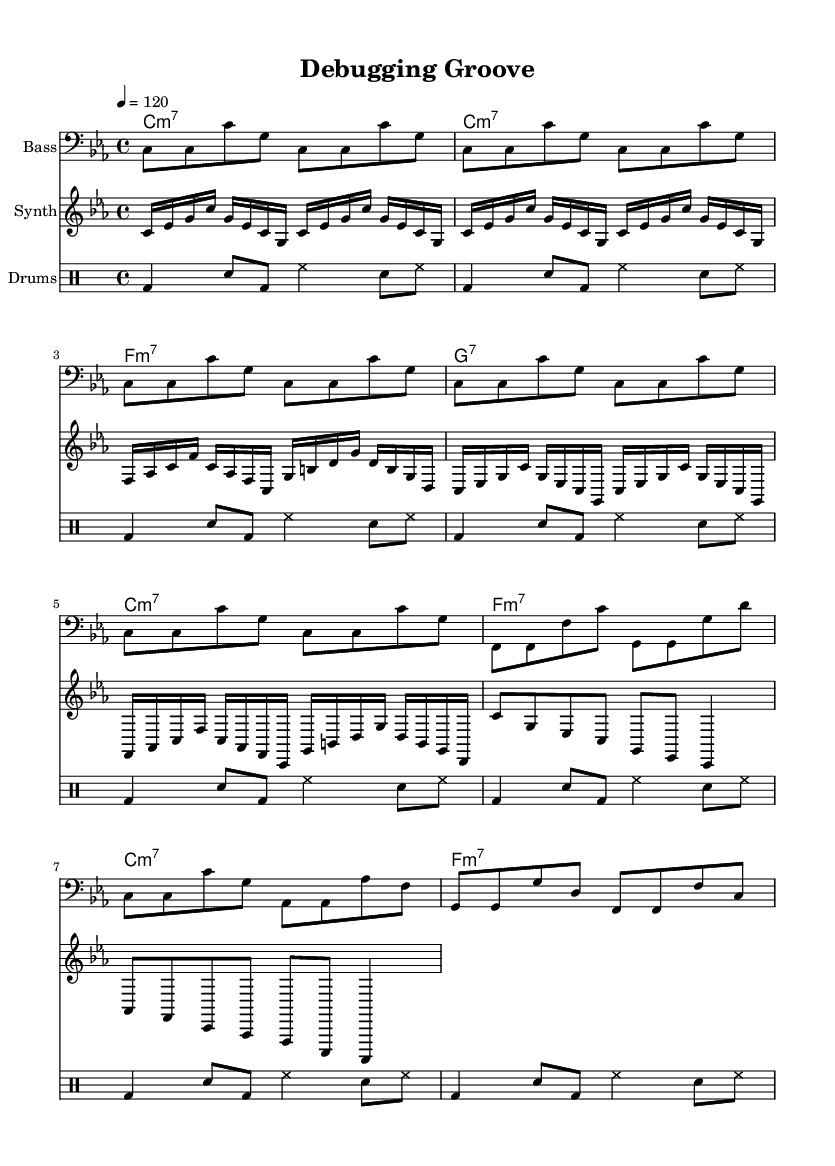What is the key signature of this music? The key signature is indicated at the beginning of the staff. Since there are three flats shown, it corresponds to C minor.
Answer: C minor What is the time signature of this music? The time signature is found at the beginning of the score, represented as a fraction. It denotes four beats per measure, thus it is 4/4.
Answer: 4/4 What is the tempo marking of this piece? The tempo marking is noted at the start of the score and is indicated by the metronome marking '4 = 120', which means there are 120 beats per minute.
Answer: 120 How many measures are there in the bass line? By counting the measures within the bass line section, there are a total of eight measures.
Answer: 8 Which chords are predominantly used in this music? The chords can be observed in the chord section, where several chord symbols are indicated. The prominent chords include C minor 7, F minor 7, and G7.
Answer: C minor 7, F minor 7, G7 What rhythmic pattern do the drums play? The rhythmic pattern for the drums can be deciphered from the drum staff. It shows a combination of bass drum, snare, and hi-hat notes repeated every two measures.
Answer: Repeat pattern What features of funk does this music exemplify? This piece showcases synchronized rhythms, a groovy bass line, and the use of syncopation, which are standard elements of funky music.
Answer: Synchronized rhythms, groovy bass 